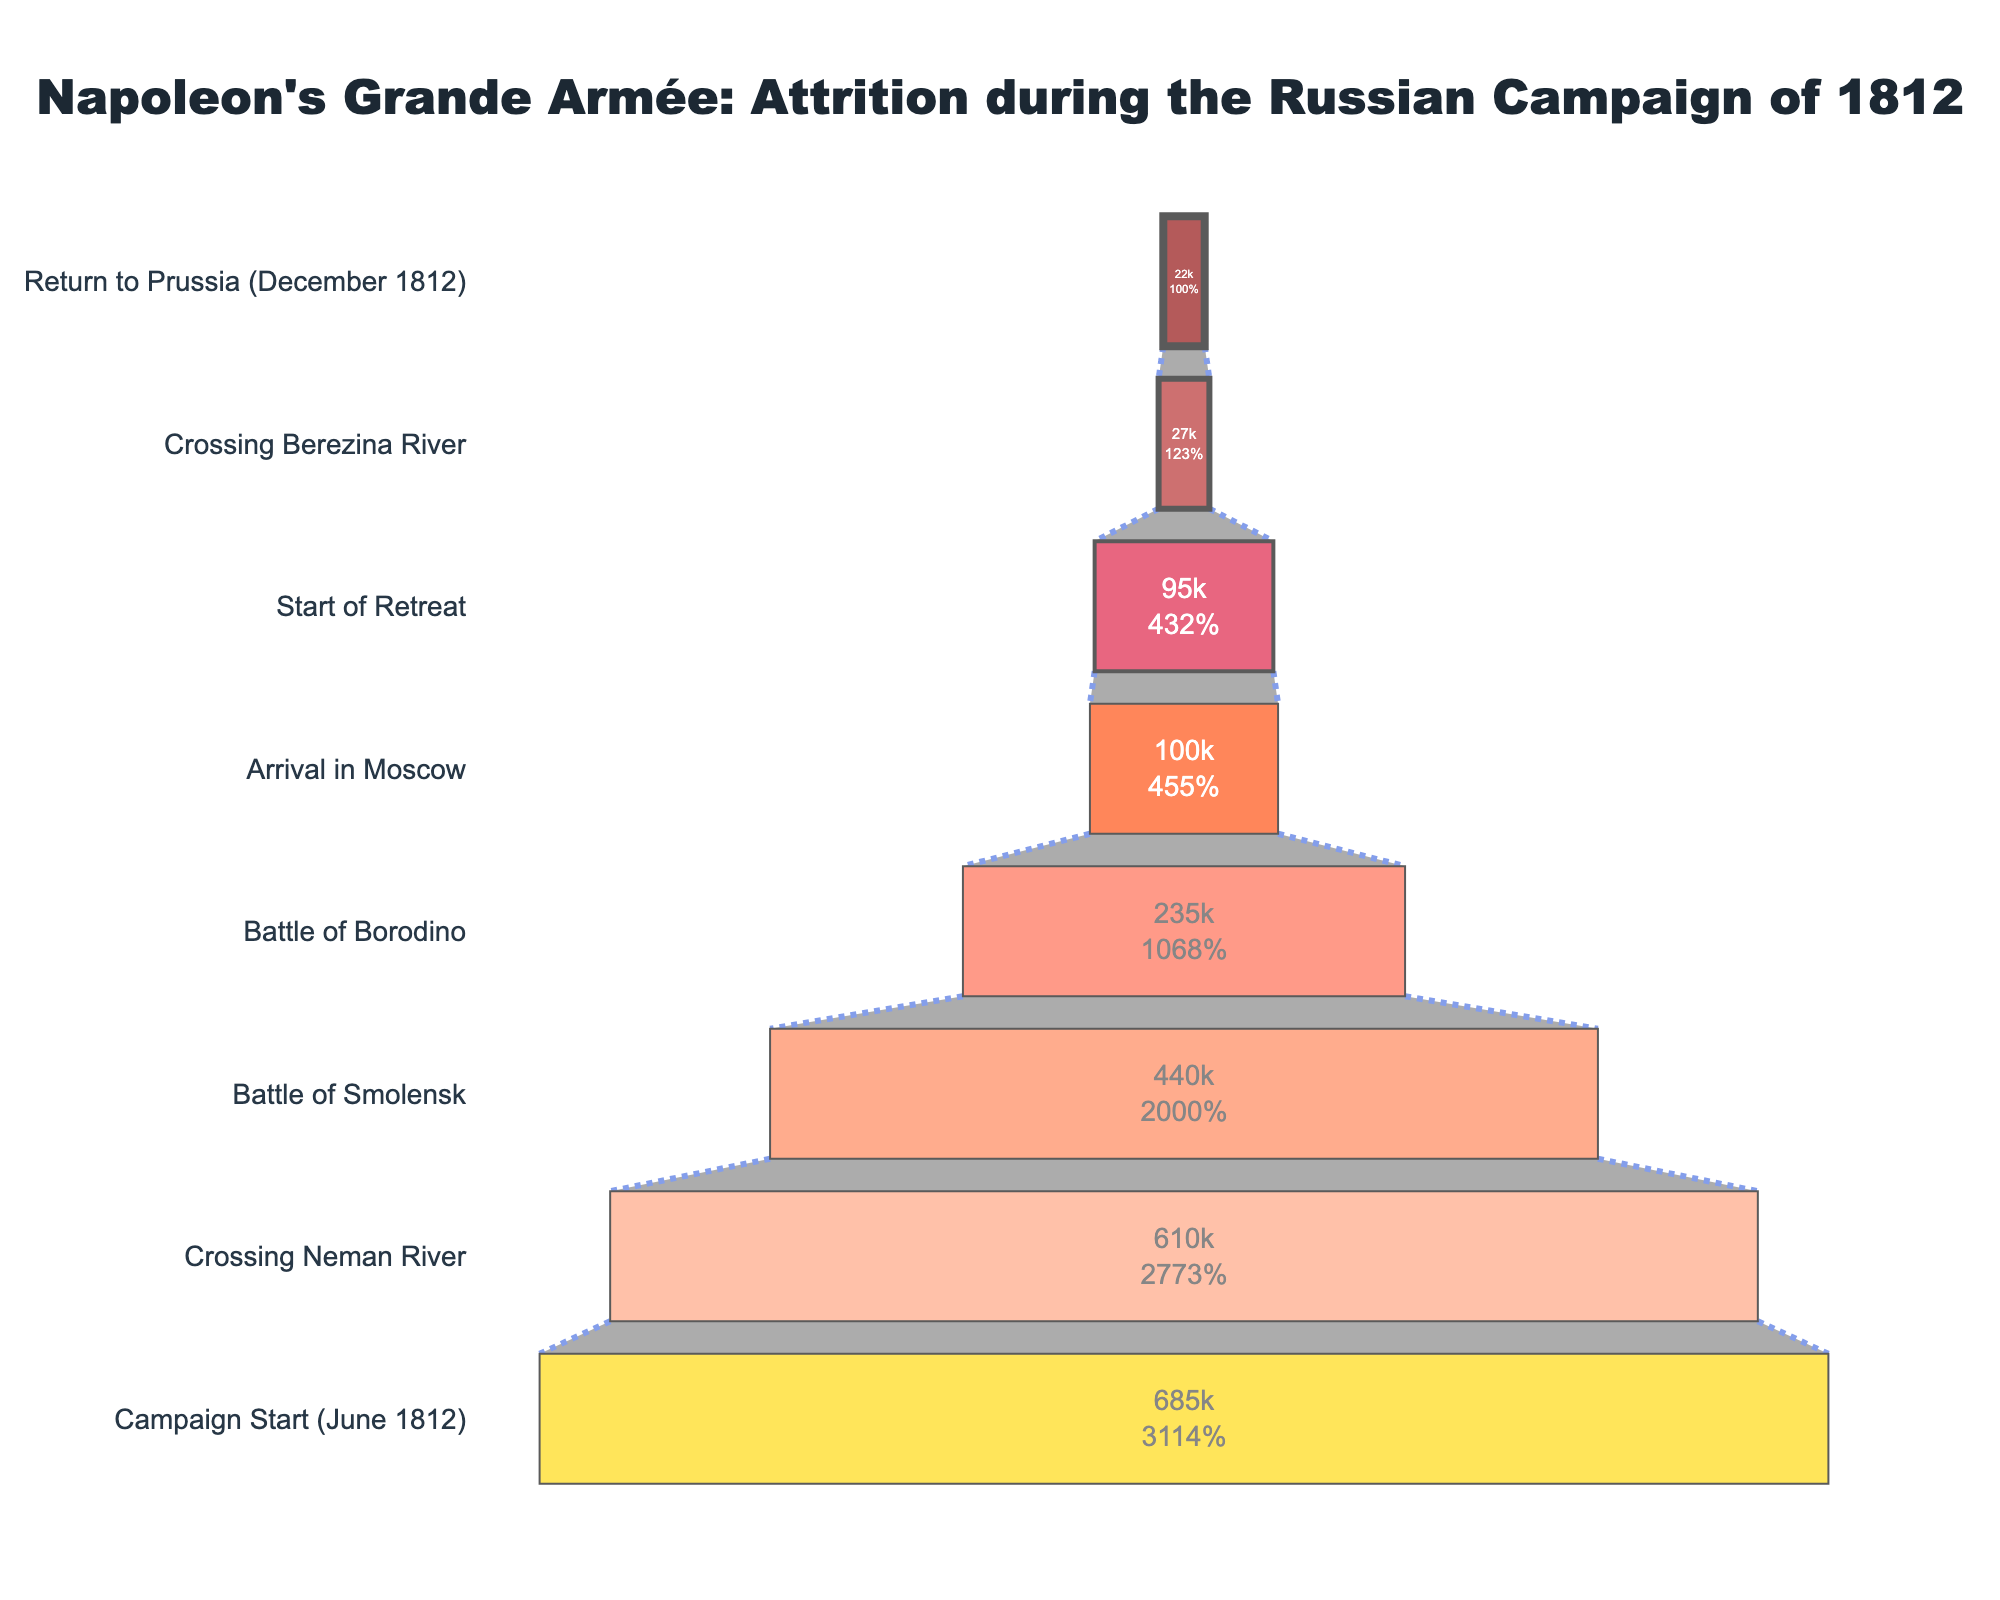What's the title of the chart? The title is often placed at the top of the chart and describes the subject of the figure. The title is "Napoleon's Grande Armée: Attrition during the Russian Campaign of 1812."
Answer: Napoleon's Grande Armée: Attrition during the Russian Campaign of 1812 What is the initial number of soldiers at the start of the campaign? The initial number of soldiers is represented by the first stage in the funnel chart, labeled "Campaign Start (June 1812)." The value is shown inside the funnel stage.
Answer: 685,000 Which stage shows the largest drop in the number of soldiers from the previous stage? To find the largest drop, we compare the decrease in the number of soldiers between each stage. The stages with the values are "Crossing Neman River" to "Battle of Smolensk" (610,000 to 440,000) and "Battle of Smolensk" to "Battle of Borodino" (440,000 to 235,000). The largest drop is from "Battle of Smolensk" to "Battle of Borodino."
Answer: Battle of Smolensk to Battle of Borodino What percentage of soldiers remained at the end of the campaign compared to the start? To calculate the percentage, we divide the number of soldiers at the end by the initial number and multiply by 100. That’s (22,000 / 685,000) * 100%.
Answer: 3.21% How many stages are represented in the funnel chart? By counting the different stages listed on the left side of the funnel chart, we observe there are eight stages.
Answer: 8 What is the percentage of initial soldiers remaining when Napoleon's army reaches Moscow? The number of soldiers at Moscow is 100,000, which can be compared to the initial number (685,000). Use the percentage formula: (100,000 / 685,000) * 100% = 14.6%.
Answer: 14.6% Compare the number of soldiers at the Battle of Borodino and at the start of the retreat. Which stage had fewer soldiers? Look at the numbers corresponding to each stage. Battle of Borodino had 235,000 soldiers, and start of the retreat had 95,000 soldiers. The latter value is smaller.
Answer: Start of Retreat How many soldiers were lost between the arrival in Moscow and the start of the retreat? Subtract the number of soldiers at "Start of Retreat" from "Arrival in Moscow" which is 100,000 - 95,000 = 5,000 soldiers.
Answer: 5,000 What is the source of the data shown in the funnel chart? The data source is indicated at the bottom of the chart in the annotation, stating "Data source: Minard's famous graphic."
Answer: Minard's famous graphic What is the smallest number of soldiers at any stage shown in the chart? By scanning through the values for each stage, the stage with the smallest number is "Return to Prussia (December 1812)" with 22,000 soldiers.
Answer: 22,000 